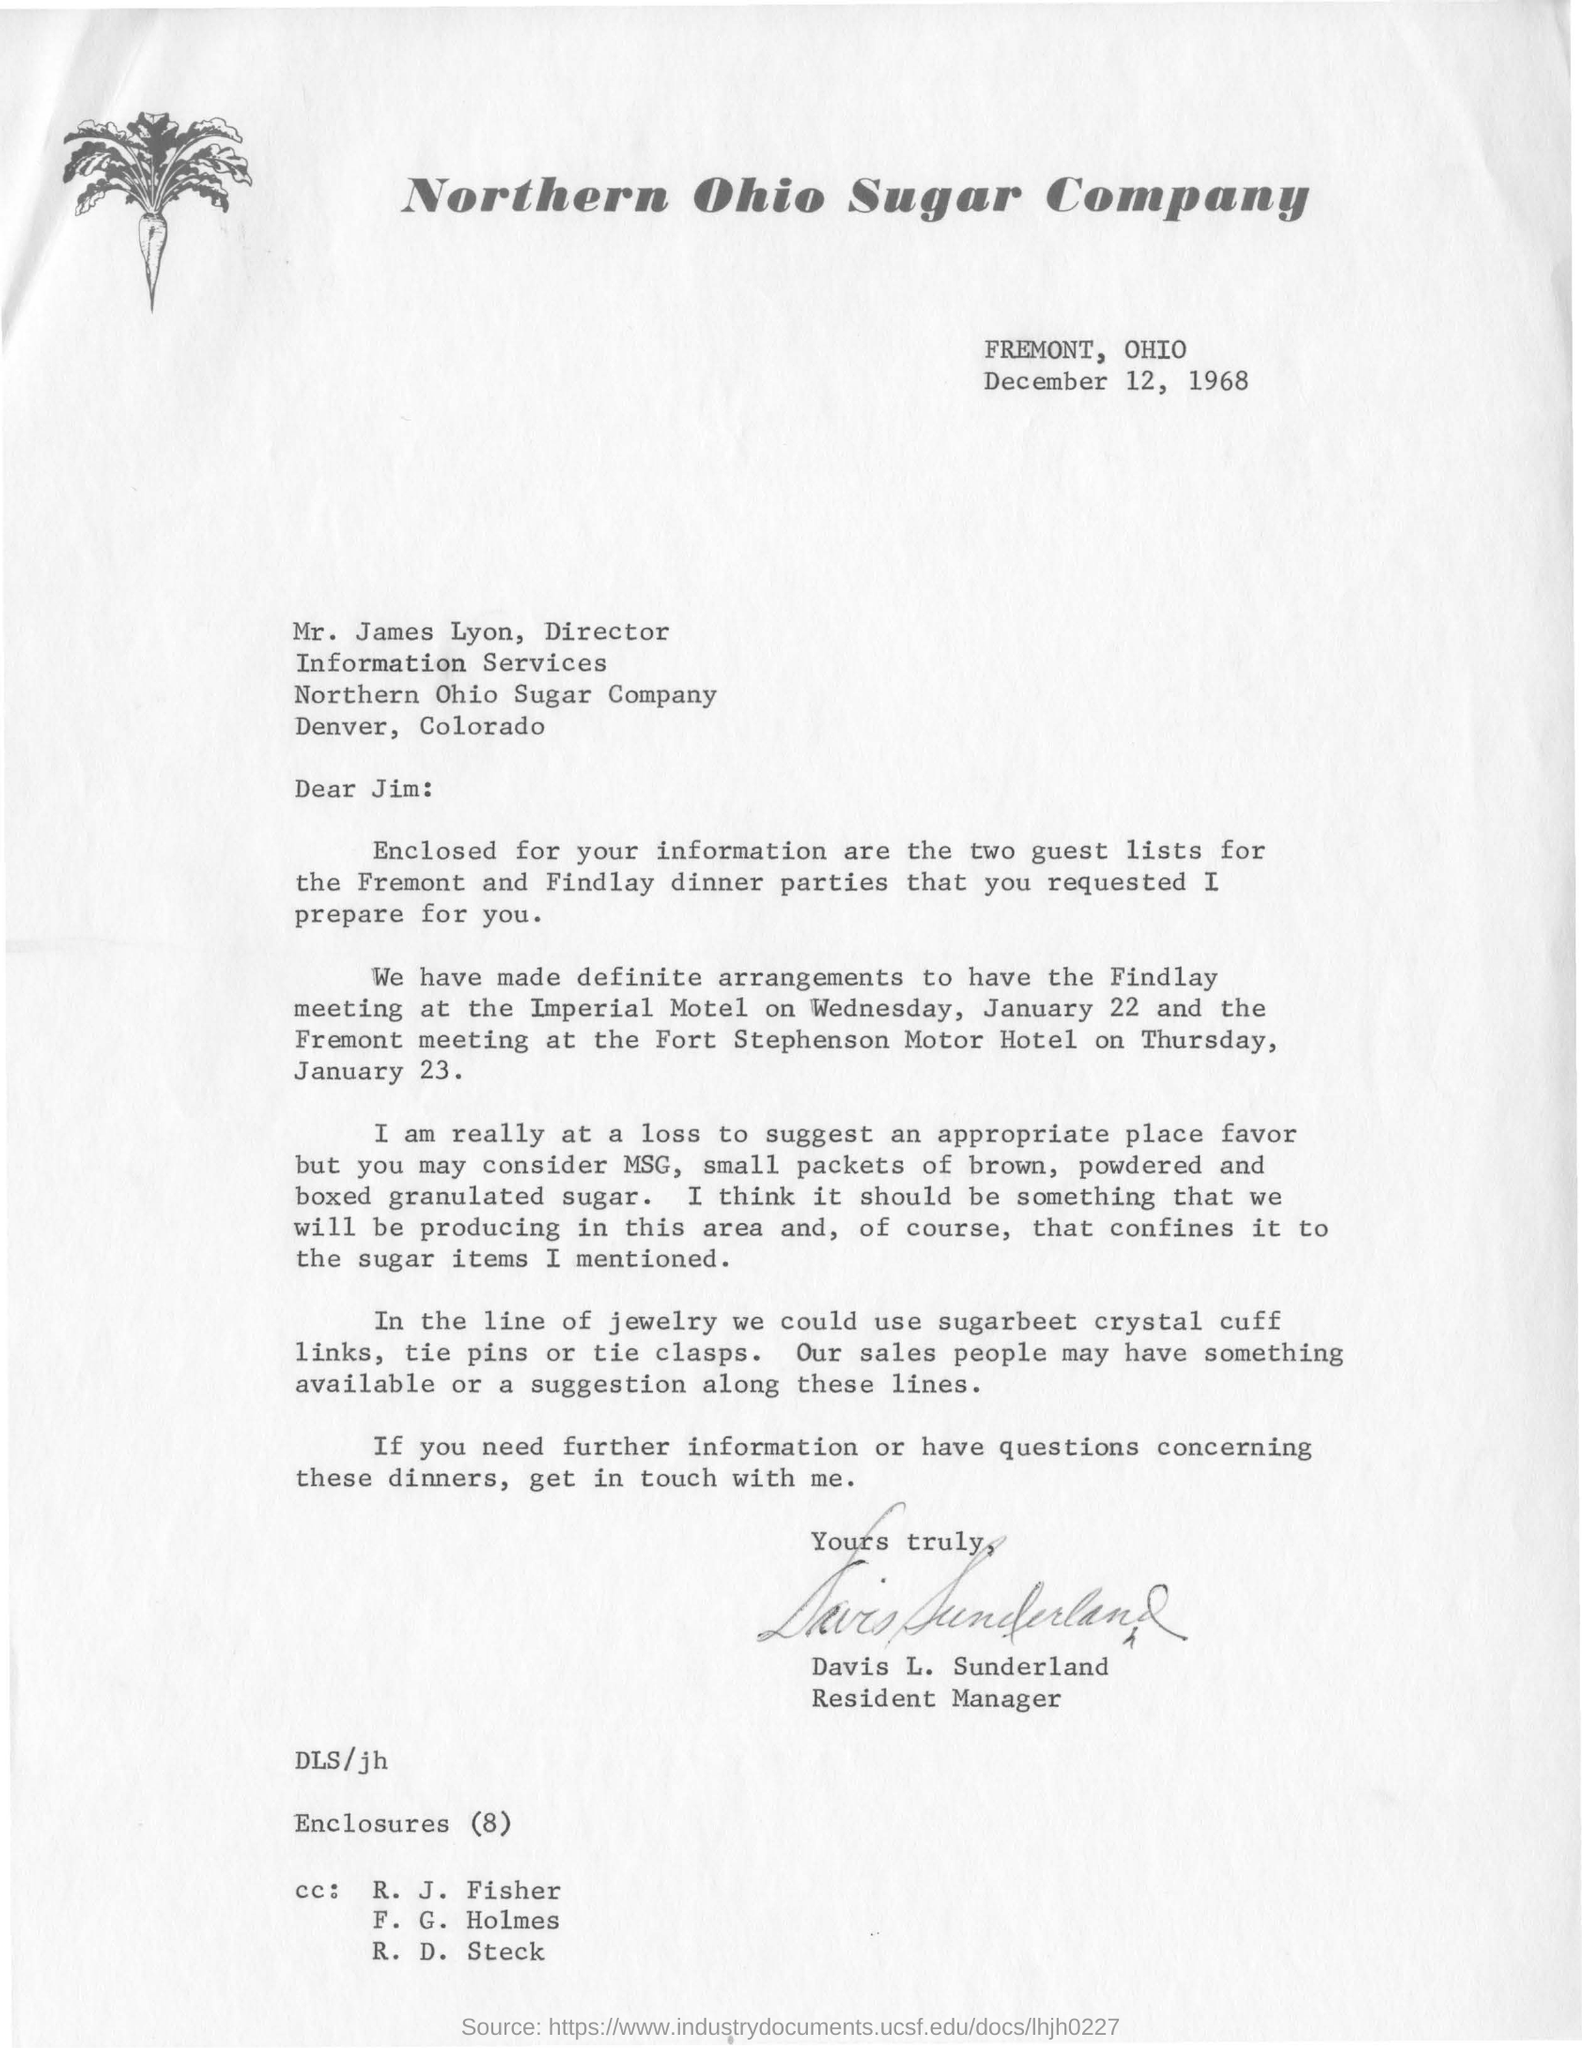What is the date mentioned above?
Your response must be concise. December 12, 1968. What is the name of the company?
Make the answer very short. Northern Ohio Sugar Company. Which company is mentioned in the letterhead?
Give a very brief answer. Northern Ohio Sugar Company. 